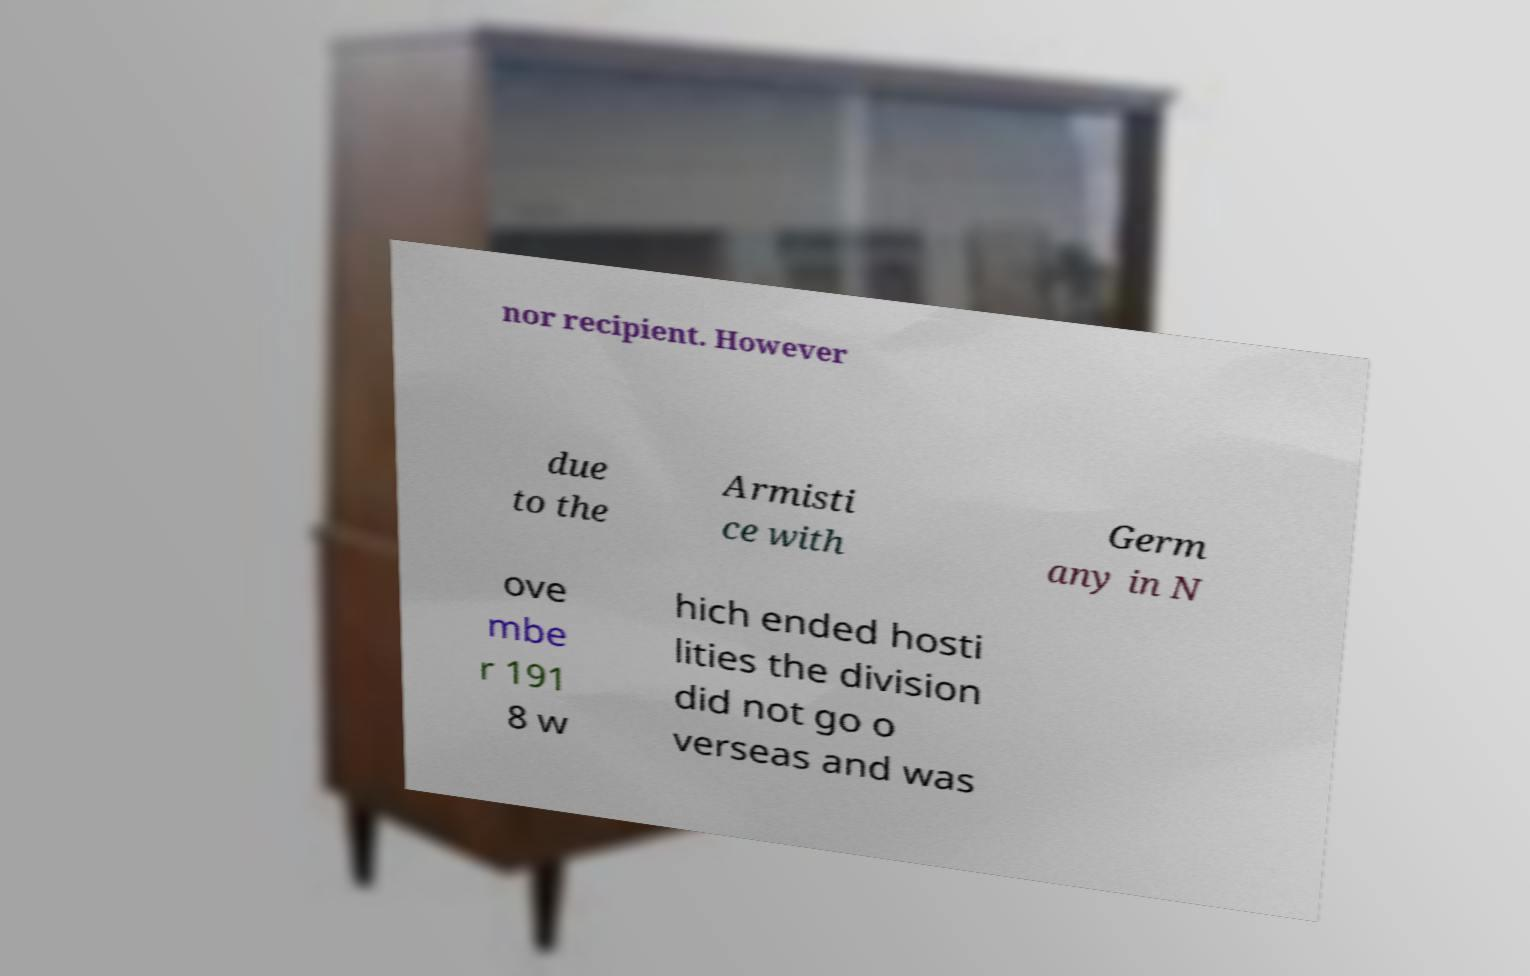What messages or text are displayed in this image? I need them in a readable, typed format. nor recipient. However due to the Armisti ce with Germ any in N ove mbe r 191 8 w hich ended hosti lities the division did not go o verseas and was 